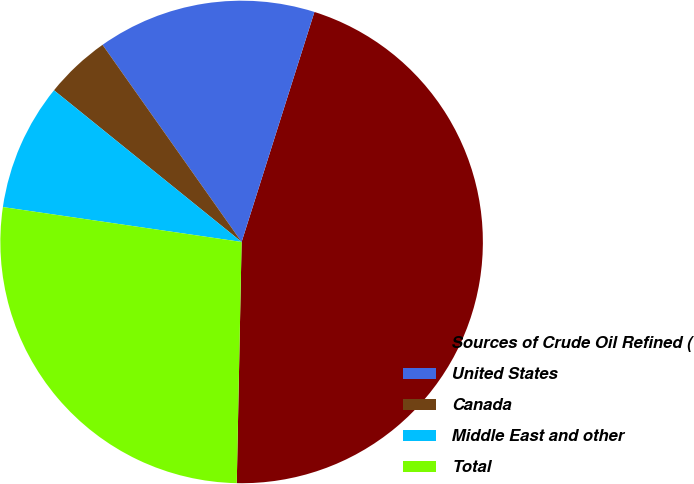Convert chart. <chart><loc_0><loc_0><loc_500><loc_500><pie_chart><fcel>Sources of Crude Oil Refined (<fcel>United States<fcel>Canada<fcel>Middle East and other<fcel>Total<nl><fcel>45.44%<fcel>14.66%<fcel>4.4%<fcel>8.51%<fcel>26.99%<nl></chart> 